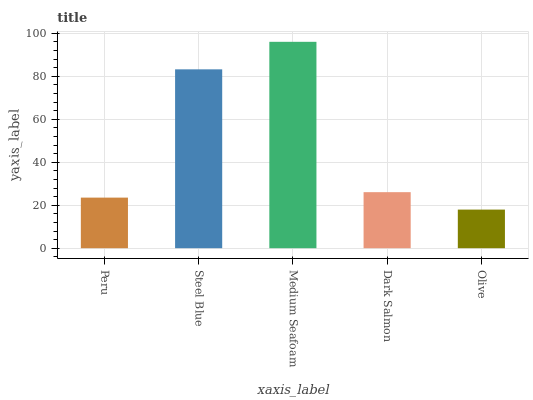Is Olive the minimum?
Answer yes or no. Yes. Is Medium Seafoam the maximum?
Answer yes or no. Yes. Is Steel Blue the minimum?
Answer yes or no. No. Is Steel Blue the maximum?
Answer yes or no. No. Is Steel Blue greater than Peru?
Answer yes or no. Yes. Is Peru less than Steel Blue?
Answer yes or no. Yes. Is Peru greater than Steel Blue?
Answer yes or no. No. Is Steel Blue less than Peru?
Answer yes or no. No. Is Dark Salmon the high median?
Answer yes or no. Yes. Is Dark Salmon the low median?
Answer yes or no. Yes. Is Olive the high median?
Answer yes or no. No. Is Steel Blue the low median?
Answer yes or no. No. 